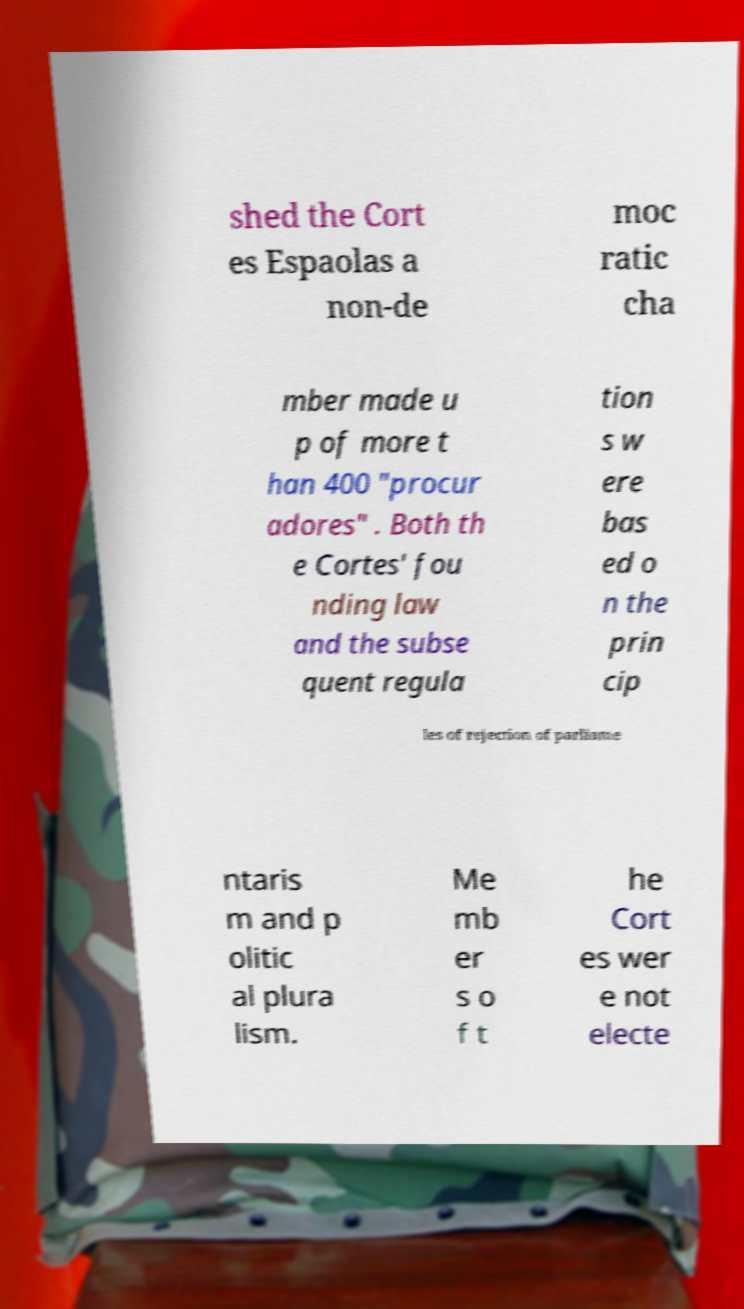Could you extract and type out the text from this image? shed the Cort es Espaolas a non-de moc ratic cha mber made u p of more t han 400 "procur adores" . Both th e Cortes' fou nding law and the subse quent regula tion s w ere bas ed o n the prin cip les of rejection of parliame ntaris m and p olitic al plura lism. Me mb er s o f t he Cort es wer e not electe 